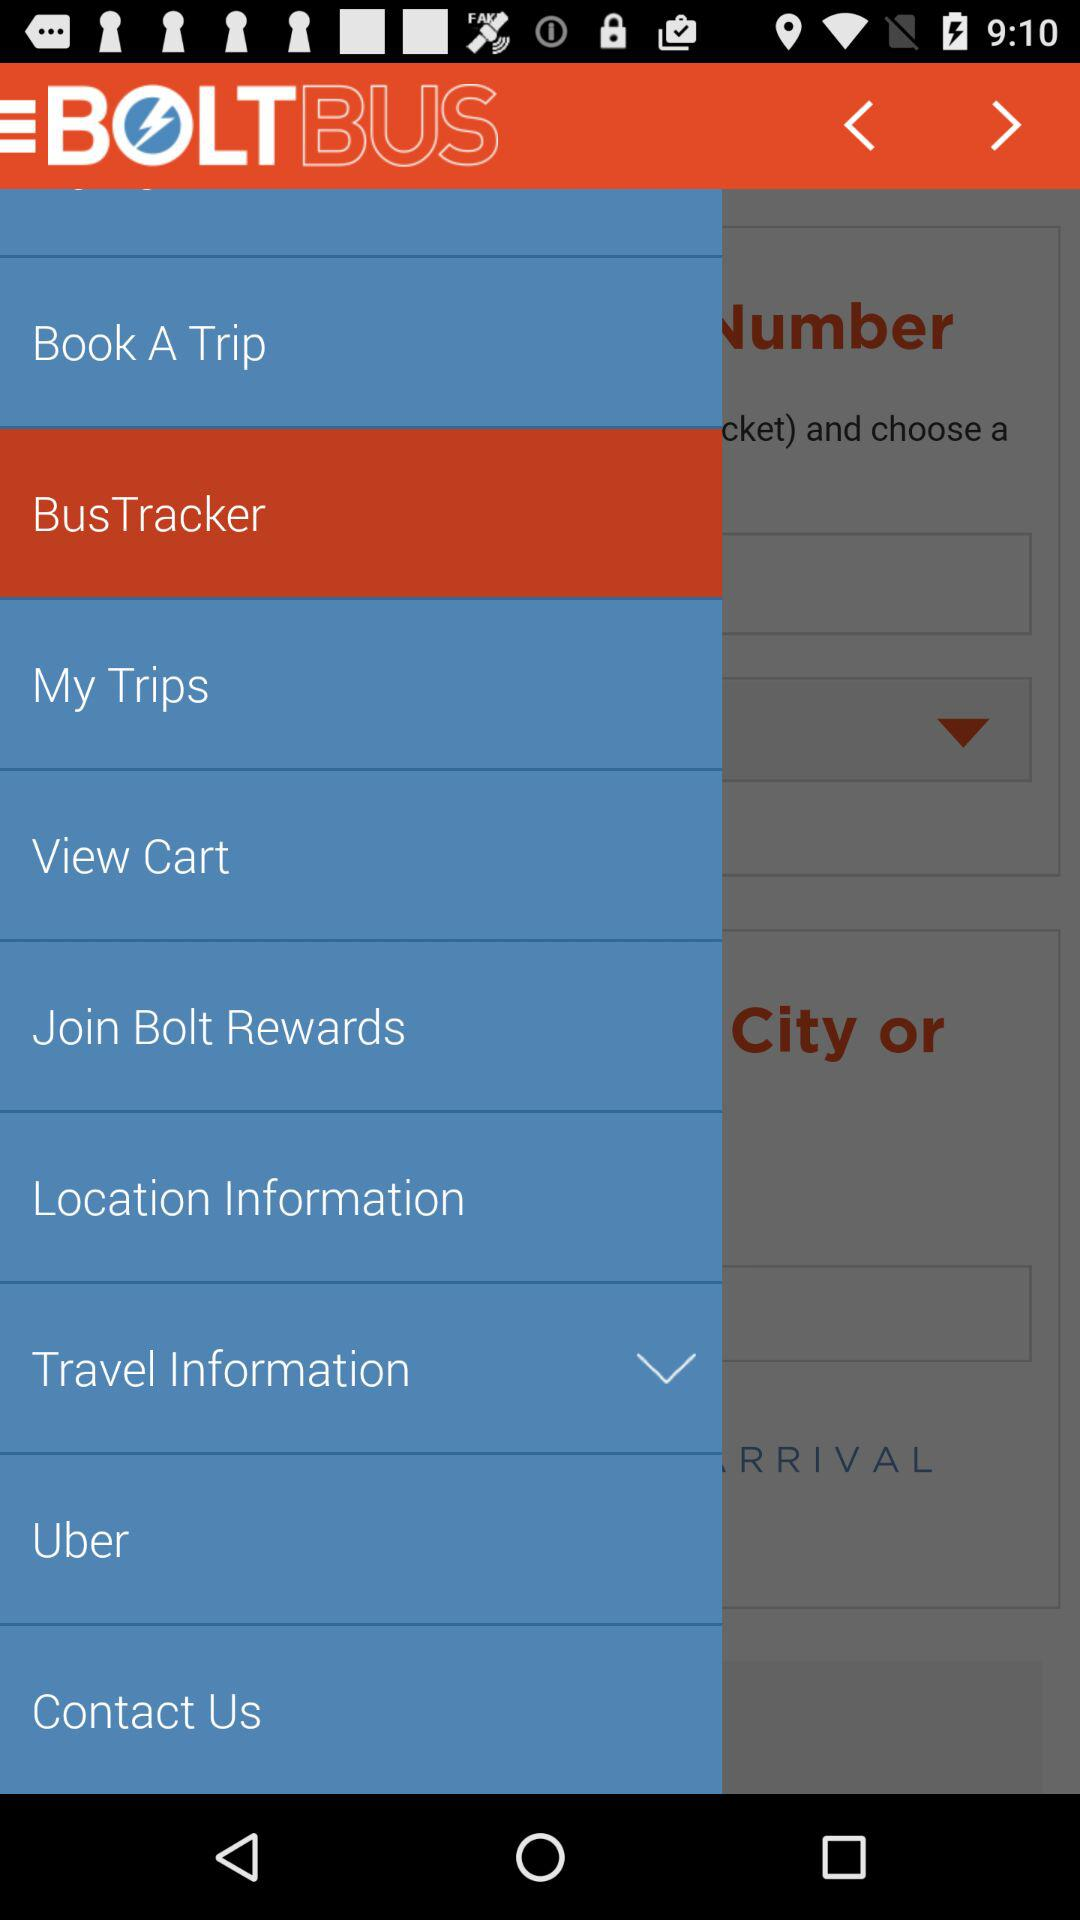What is the name of the application? The name of the application is "BOLTBUS". 